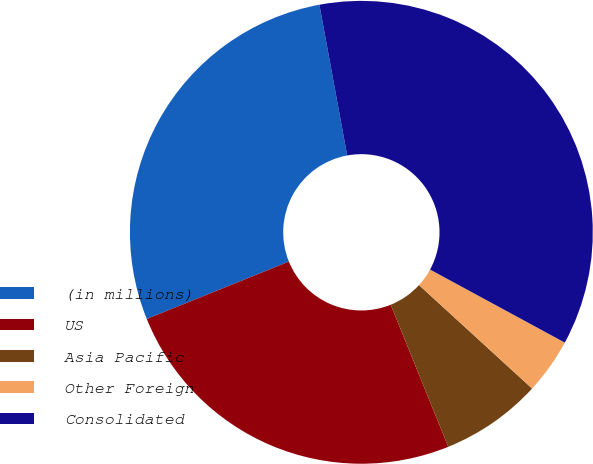<chart> <loc_0><loc_0><loc_500><loc_500><pie_chart><fcel>(in millions)<fcel>US<fcel>Asia Pacific<fcel>Other Foreign<fcel>Consolidated<nl><fcel>28.21%<fcel>25.02%<fcel>7.08%<fcel>3.89%<fcel>35.81%<nl></chart> 